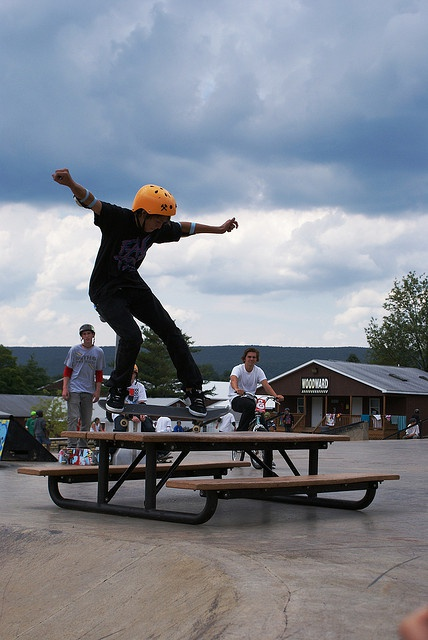Describe the objects in this image and their specific colors. I can see people in darkgray, black, lightgray, brown, and maroon tones, bench in darkgray, black, and gray tones, people in darkgray, gray, black, and maroon tones, bench in darkgray, black, gray, and maroon tones, and people in darkgray, black, and gray tones in this image. 